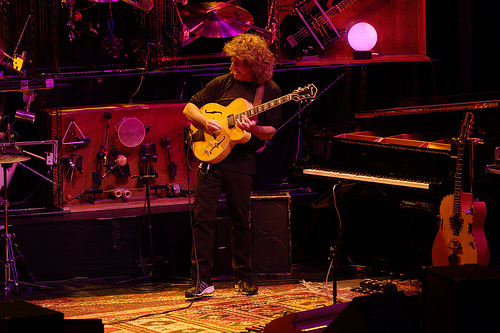<image>
Is the light in front of the man? No. The light is not in front of the man. The spatial positioning shows a different relationship between these objects. 